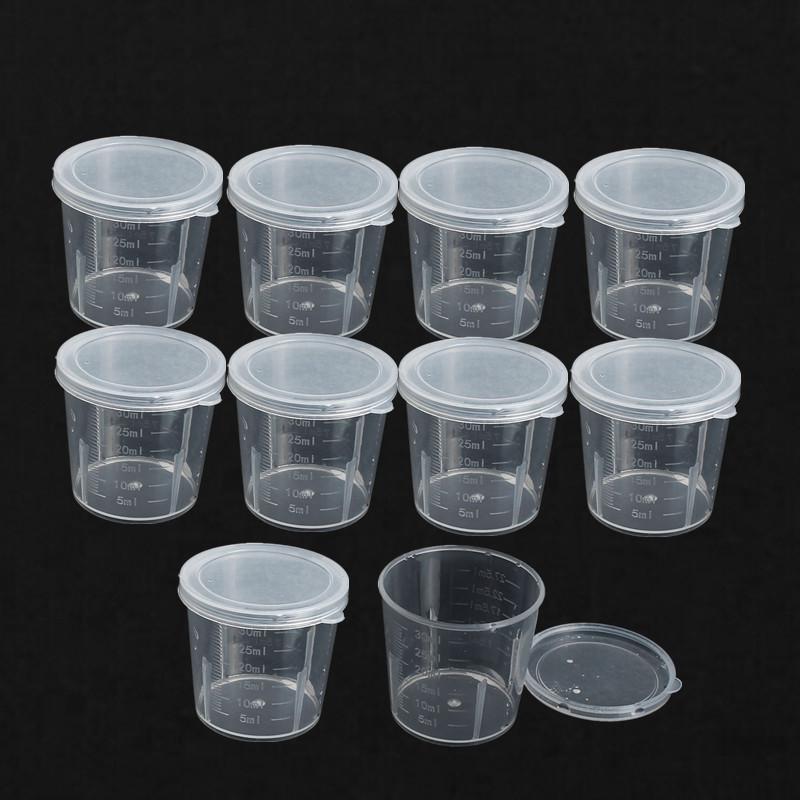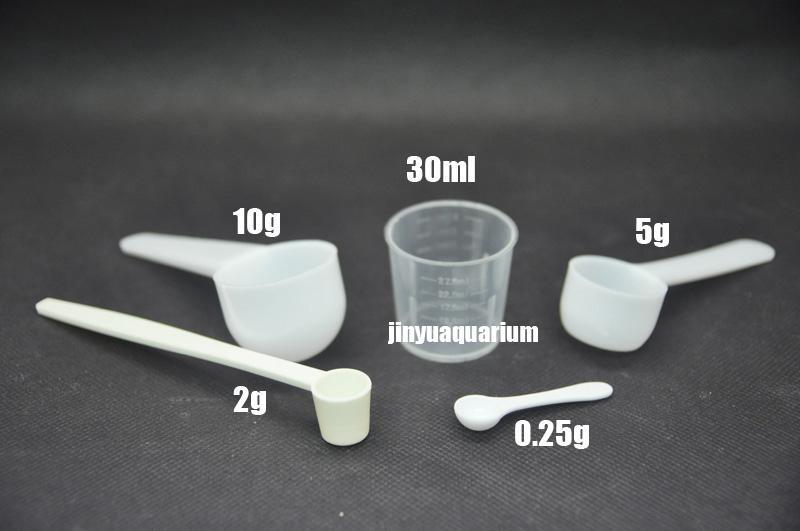The first image is the image on the left, the second image is the image on the right. For the images displayed, is the sentence "In total, there are two cups and one spoon." factually correct? Answer yes or no. No. 